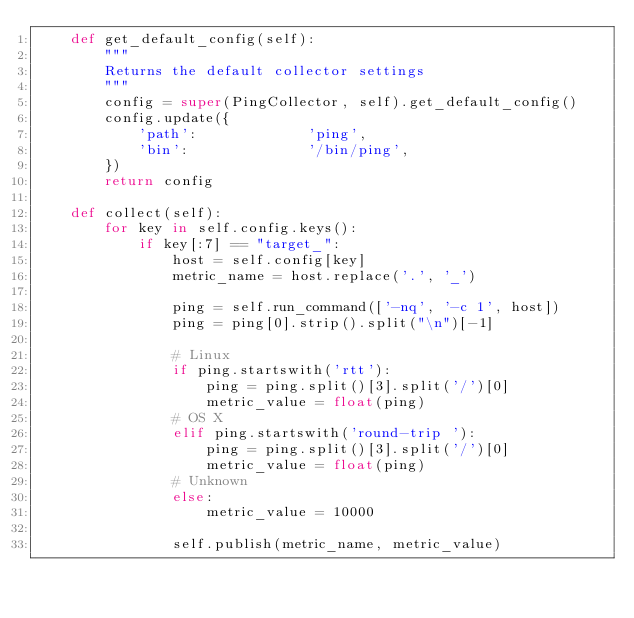<code> <loc_0><loc_0><loc_500><loc_500><_Python_>    def get_default_config(self):
        """
        Returns the default collector settings
        """
        config = super(PingCollector, self).get_default_config()
        config.update({
            'path':             'ping',
            'bin':              '/bin/ping',
        })
        return config

    def collect(self):
        for key in self.config.keys():
            if key[:7] == "target_":
                host = self.config[key]
                metric_name = host.replace('.', '_')

                ping = self.run_command(['-nq', '-c 1', host])
                ping = ping[0].strip().split("\n")[-1]

                # Linux
                if ping.startswith('rtt'):
                    ping = ping.split()[3].split('/')[0]
                    metric_value = float(ping)
                # OS X
                elif ping.startswith('round-trip '):
                    ping = ping.split()[3].split('/')[0]
                    metric_value = float(ping)
                # Unknown
                else:
                    metric_value = 10000

                self.publish(metric_name, metric_value)
</code> 